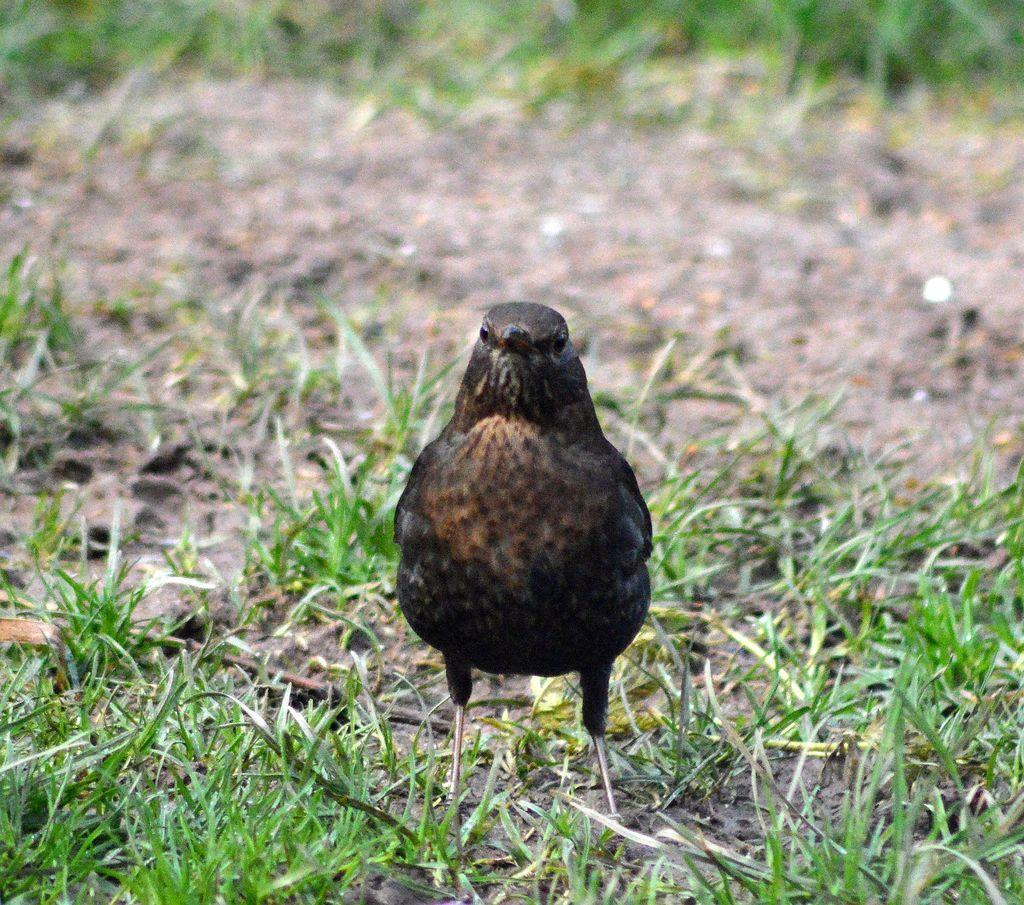What type of vegetation is present on the ground in the image? There is grass on the ground in the image. What animal can be seen on the ground in the image? There is a bird standing on the ground in the image. Can you describe the background of the image? The background of the image is blurry. What type of fight is taking place in the image? There is no fight present in the image; it features a bird standing on grass with a blurry background. How many copies of the bird can be seen in the image? There is only one bird visible in the image, so there are no copies. 